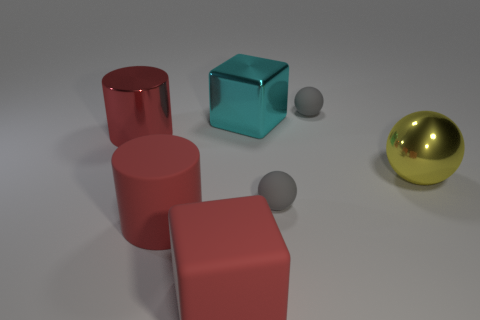Subtract all tiny spheres. How many spheres are left? 1 Subtract all gray cylinders. How many gray spheres are left? 2 Subtract 1 balls. How many balls are left? 2 Subtract all brown balls. Subtract all purple cylinders. How many balls are left? 3 Add 1 tiny gray rubber spheres. How many objects exist? 8 Subtract all cylinders. How many objects are left? 5 Subtract 1 red blocks. How many objects are left? 6 Subtract all large cubes. Subtract all big rubber cylinders. How many objects are left? 4 Add 5 shiny balls. How many shiny balls are left? 6 Add 1 cyan things. How many cyan things exist? 2 